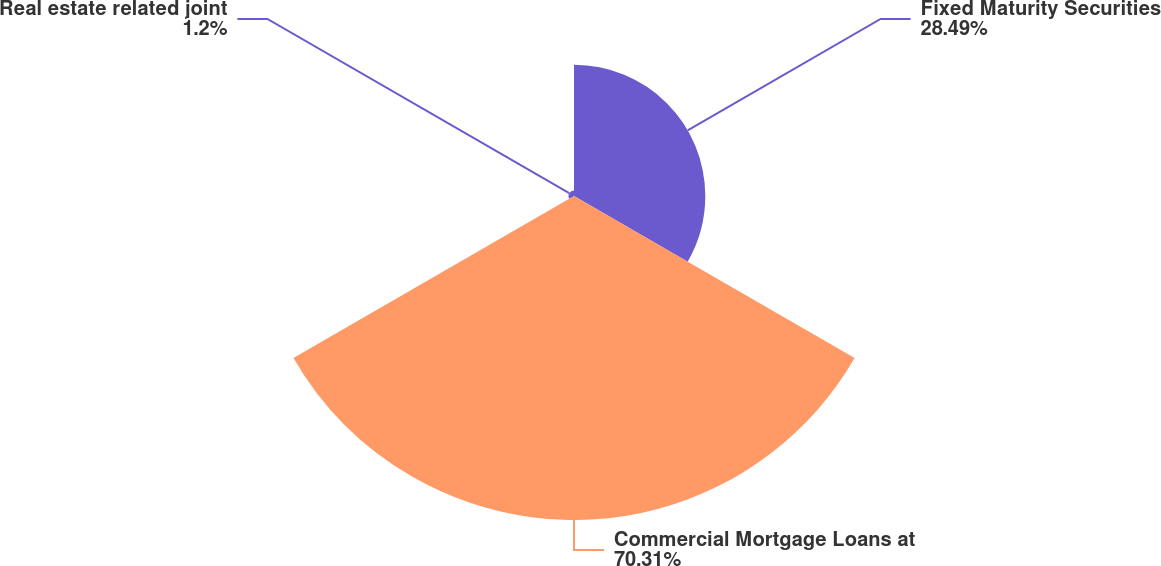<chart> <loc_0><loc_0><loc_500><loc_500><pie_chart><fcel>Fixed Maturity Securities<fcel>Commercial Mortgage Loans at<fcel>Real estate related joint<nl><fcel>28.49%<fcel>70.31%<fcel>1.2%<nl></chart> 